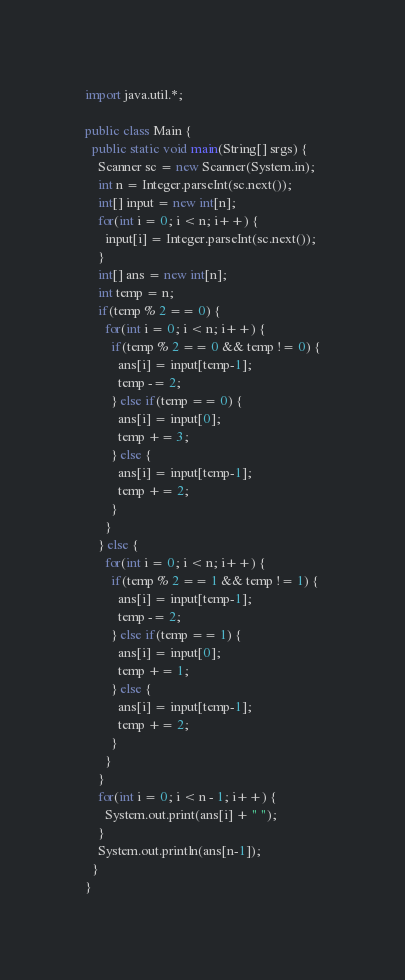Convert code to text. <code><loc_0><loc_0><loc_500><loc_500><_Java_>import java.util.*;

public class Main {
  public static void main(String[] srgs) {
    Scanner sc = new Scanner(System.in);
    int n = Integer.parseInt(sc.next());
    int[] input = new int[n];
    for(int i = 0; i < n; i++) {
      input[i] = Integer.parseInt(sc.next());
    }
    int[] ans = new int[n];
    int temp = n;
    if(temp % 2 == 0) {
      for(int i = 0; i < n; i++) {
        if(temp % 2 == 0 && temp != 0) {
          ans[i] = input[temp-1];
          temp -= 2;
        } else if(temp == 0) {
          ans[i] = input[0];
          temp += 3;
        } else {
          ans[i] = input[temp-1];
          temp += 2;
        }
      }
    } else {
      for(int i = 0; i < n; i++) {
        if(temp % 2 == 1 && temp != 1) {
          ans[i] = input[temp-1];
          temp -= 2;
        } else if(temp == 1) {
          ans[i] = input[0];
          temp += 1;
        } else {
          ans[i] = input[temp-1];
          temp += 2;
        }
      }
    }
    for(int i = 0; i < n - 1; i++) {
      System.out.print(ans[i] + " ");
    }
    System.out.println(ans[n-1]);
  }
}
</code> 